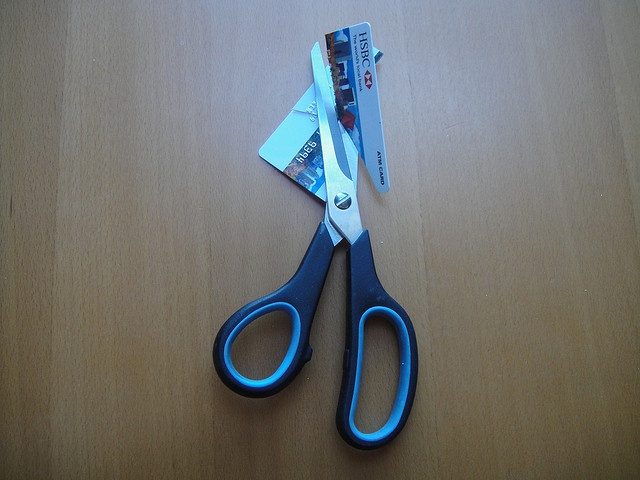Describe the objects in this image and their specific colors. I can see scissors in gray, black, navy, and lightblue tones in this image. 